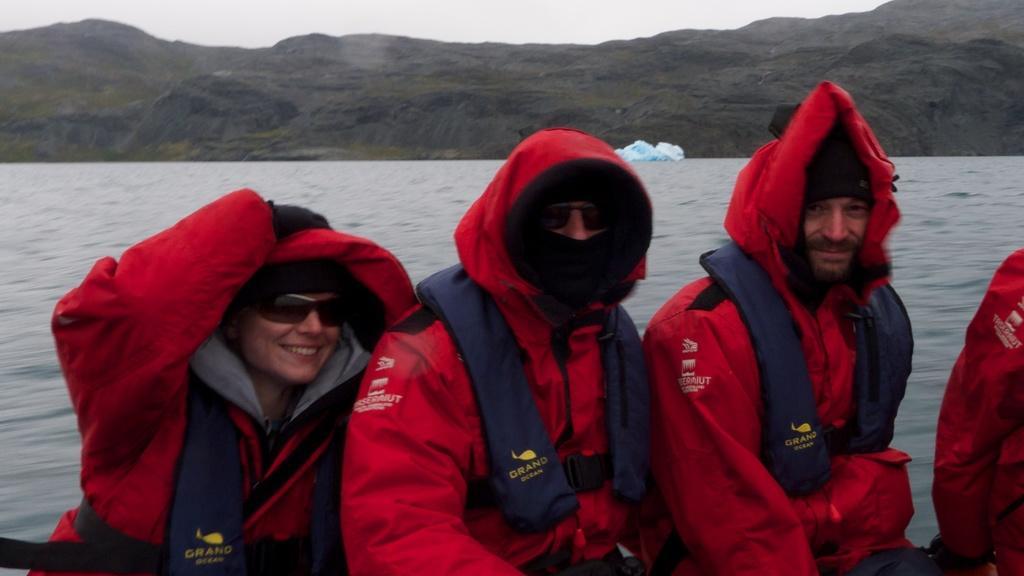In one or two sentences, can you explain what this image depicts? At the bottom I can see few people wearing red color jackets and looking at the picture. The woman is smiling who is on the left side. In the background, I can see the water and a hill. At the top of the image I can see the sky. 